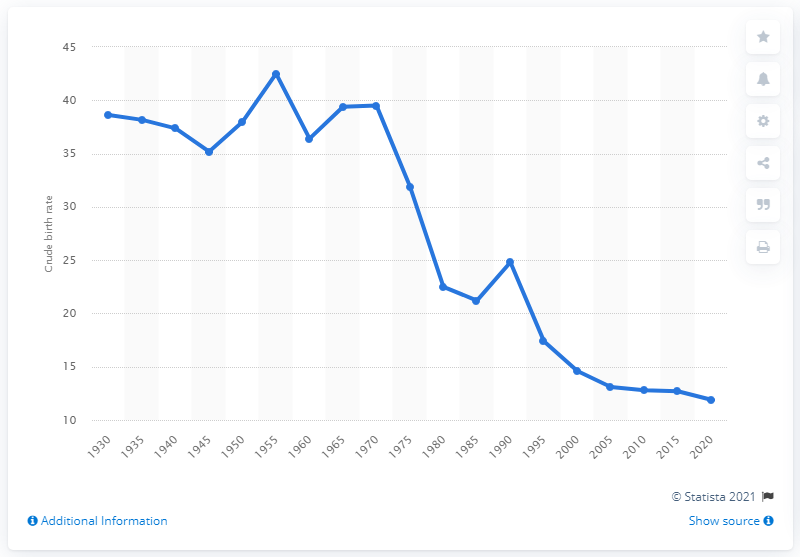Indicate a few pertinent items in this graphic. The crude birth rate in China reached its highest recorded figure in 1955. 